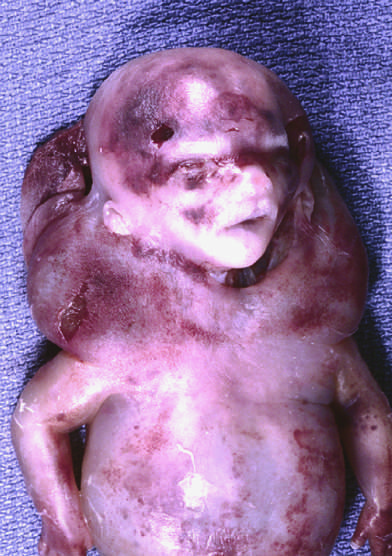what are cystic hygromas characteristically seen with, but not limited to?
Answer the question using a single word or phrase. Constitutional chromosomal anomalies such as 45 